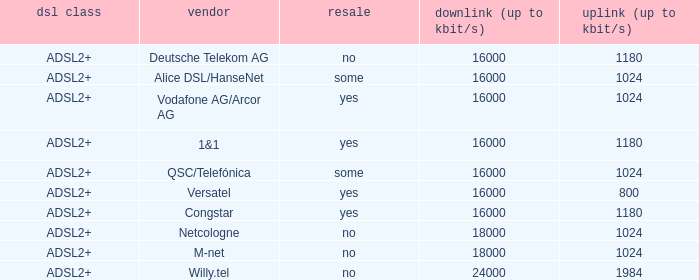What is download bandwith where the provider is deutsche telekom ag? 16000.0. 